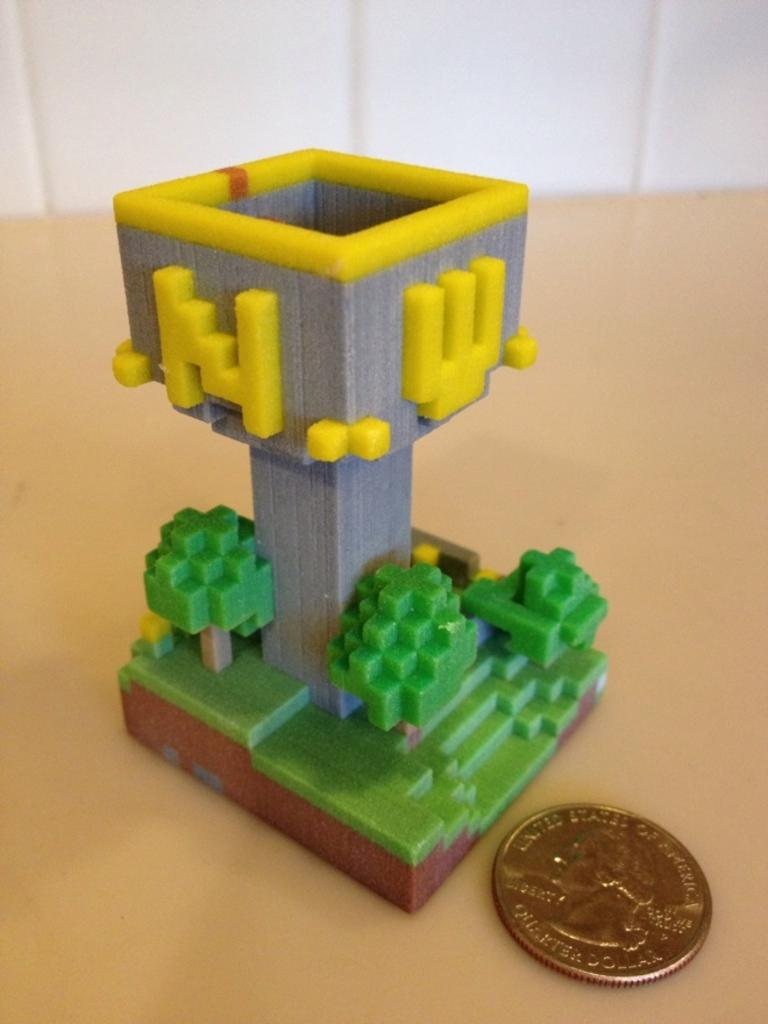What type of toy is in the image? There is a Lego toy in the image. What object is located beside the Lego toy? There is a coin beside the Lego toy in the image. What type of tax is being discussed in the image? There is no discussion of tax in the image; it features a Lego toy and a coin. Can you observe any signs of the Lego toy being crushed in the image? There is no indication of the Lego toy being crushed in the image. 